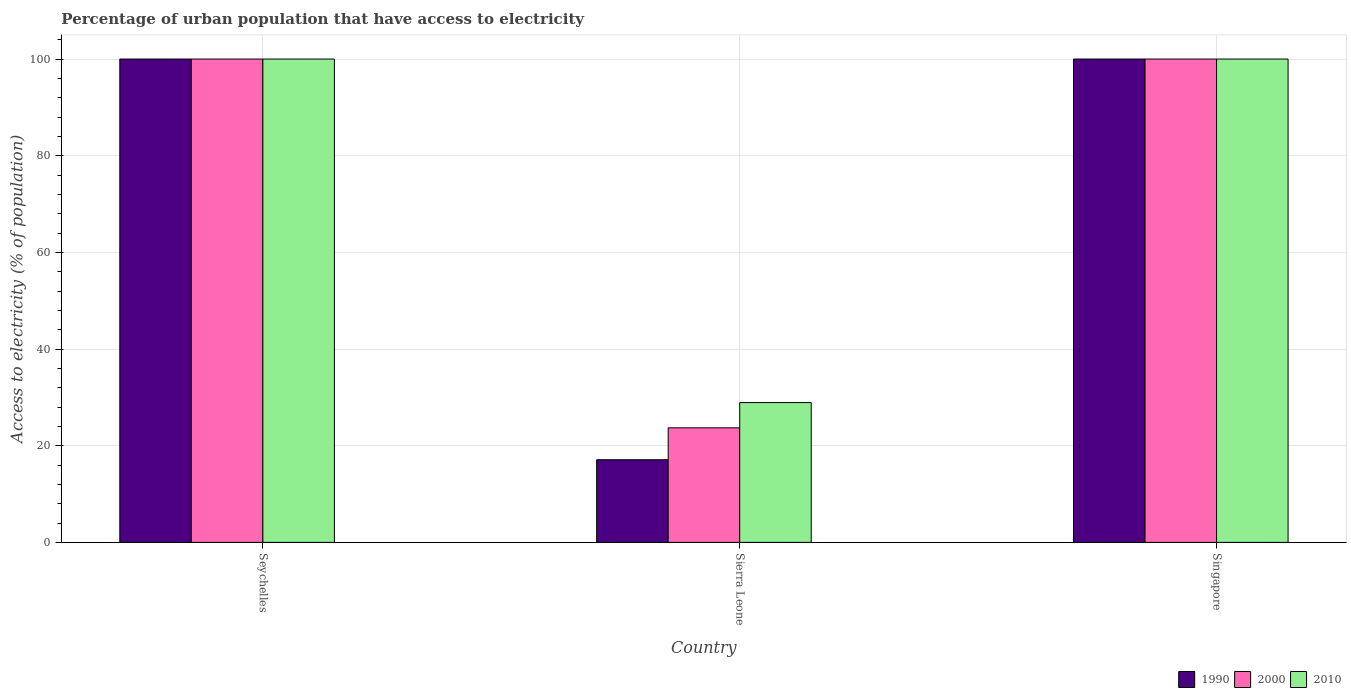Are the number of bars per tick equal to the number of legend labels?
Provide a short and direct response. Yes. How many bars are there on the 2nd tick from the left?
Your response must be concise. 3. What is the label of the 3rd group of bars from the left?
Provide a succinct answer. Singapore. In how many cases, is the number of bars for a given country not equal to the number of legend labels?
Provide a short and direct response. 0. What is the percentage of urban population that have access to electricity in 2000 in Singapore?
Offer a very short reply. 100. Across all countries, what is the maximum percentage of urban population that have access to electricity in 2010?
Provide a succinct answer. 100. Across all countries, what is the minimum percentage of urban population that have access to electricity in 1990?
Provide a short and direct response. 17.1. In which country was the percentage of urban population that have access to electricity in 1990 maximum?
Give a very brief answer. Seychelles. In which country was the percentage of urban population that have access to electricity in 2000 minimum?
Offer a terse response. Sierra Leone. What is the total percentage of urban population that have access to electricity in 2010 in the graph?
Offer a terse response. 228.92. What is the difference between the percentage of urban population that have access to electricity in 1990 in Sierra Leone and that in Singapore?
Provide a succinct answer. -82.9. What is the difference between the percentage of urban population that have access to electricity in 2010 in Sierra Leone and the percentage of urban population that have access to electricity in 2000 in Singapore?
Keep it short and to the point. -71.08. What is the average percentage of urban population that have access to electricity in 2010 per country?
Offer a terse response. 76.31. In how many countries, is the percentage of urban population that have access to electricity in 2010 greater than 64 %?
Ensure brevity in your answer.  2. What is the ratio of the percentage of urban population that have access to electricity in 1990 in Sierra Leone to that in Singapore?
Your answer should be very brief. 0.17. Is the percentage of urban population that have access to electricity in 2010 in Seychelles less than that in Sierra Leone?
Offer a very short reply. No. What is the difference between the highest and the second highest percentage of urban population that have access to electricity in 1990?
Offer a terse response. -82.9. What is the difference between the highest and the lowest percentage of urban population that have access to electricity in 2010?
Provide a succinct answer. 71.08. In how many countries, is the percentage of urban population that have access to electricity in 2010 greater than the average percentage of urban population that have access to electricity in 2010 taken over all countries?
Your answer should be very brief. 2. What does the 3rd bar from the right in Seychelles represents?
Your answer should be very brief. 1990. Is it the case that in every country, the sum of the percentage of urban population that have access to electricity in 1990 and percentage of urban population that have access to electricity in 2000 is greater than the percentage of urban population that have access to electricity in 2010?
Give a very brief answer. Yes. Are all the bars in the graph horizontal?
Ensure brevity in your answer.  No. How many countries are there in the graph?
Provide a succinct answer. 3. Does the graph contain any zero values?
Your answer should be very brief. No. Does the graph contain grids?
Your answer should be compact. Yes. How are the legend labels stacked?
Offer a terse response. Horizontal. What is the title of the graph?
Ensure brevity in your answer.  Percentage of urban population that have access to electricity. Does "2003" appear as one of the legend labels in the graph?
Offer a very short reply. No. What is the label or title of the Y-axis?
Offer a terse response. Access to electricity (% of population). What is the Access to electricity (% of population) of 1990 in Seychelles?
Give a very brief answer. 100. What is the Access to electricity (% of population) of 1990 in Sierra Leone?
Your answer should be compact. 17.1. What is the Access to electricity (% of population) in 2000 in Sierra Leone?
Provide a short and direct response. 23.7. What is the Access to electricity (% of population) in 2010 in Sierra Leone?
Provide a succinct answer. 28.92. What is the Access to electricity (% of population) of 1990 in Singapore?
Provide a short and direct response. 100. What is the Access to electricity (% of population) in 2000 in Singapore?
Your answer should be compact. 100. What is the Access to electricity (% of population) of 2010 in Singapore?
Your response must be concise. 100. Across all countries, what is the maximum Access to electricity (% of population) of 1990?
Keep it short and to the point. 100. Across all countries, what is the maximum Access to electricity (% of population) of 2010?
Your answer should be compact. 100. Across all countries, what is the minimum Access to electricity (% of population) of 1990?
Your response must be concise. 17.1. Across all countries, what is the minimum Access to electricity (% of population) of 2000?
Your answer should be compact. 23.7. Across all countries, what is the minimum Access to electricity (% of population) of 2010?
Your answer should be compact. 28.92. What is the total Access to electricity (% of population) in 1990 in the graph?
Keep it short and to the point. 217.1. What is the total Access to electricity (% of population) of 2000 in the graph?
Ensure brevity in your answer.  223.7. What is the total Access to electricity (% of population) of 2010 in the graph?
Provide a short and direct response. 228.92. What is the difference between the Access to electricity (% of population) in 1990 in Seychelles and that in Sierra Leone?
Your answer should be very brief. 82.9. What is the difference between the Access to electricity (% of population) of 2000 in Seychelles and that in Sierra Leone?
Offer a terse response. 76.3. What is the difference between the Access to electricity (% of population) in 2010 in Seychelles and that in Sierra Leone?
Give a very brief answer. 71.08. What is the difference between the Access to electricity (% of population) in 2000 in Seychelles and that in Singapore?
Your answer should be compact. 0. What is the difference between the Access to electricity (% of population) in 1990 in Sierra Leone and that in Singapore?
Give a very brief answer. -82.9. What is the difference between the Access to electricity (% of population) in 2000 in Sierra Leone and that in Singapore?
Keep it short and to the point. -76.3. What is the difference between the Access to electricity (% of population) of 2010 in Sierra Leone and that in Singapore?
Provide a short and direct response. -71.08. What is the difference between the Access to electricity (% of population) in 1990 in Seychelles and the Access to electricity (% of population) in 2000 in Sierra Leone?
Offer a terse response. 76.3. What is the difference between the Access to electricity (% of population) of 1990 in Seychelles and the Access to electricity (% of population) of 2010 in Sierra Leone?
Make the answer very short. 71.08. What is the difference between the Access to electricity (% of population) of 2000 in Seychelles and the Access to electricity (% of population) of 2010 in Sierra Leone?
Your answer should be very brief. 71.08. What is the difference between the Access to electricity (% of population) in 1990 in Seychelles and the Access to electricity (% of population) in 2010 in Singapore?
Keep it short and to the point. 0. What is the difference between the Access to electricity (% of population) in 1990 in Sierra Leone and the Access to electricity (% of population) in 2000 in Singapore?
Keep it short and to the point. -82.9. What is the difference between the Access to electricity (% of population) of 1990 in Sierra Leone and the Access to electricity (% of population) of 2010 in Singapore?
Your response must be concise. -82.9. What is the difference between the Access to electricity (% of population) in 2000 in Sierra Leone and the Access to electricity (% of population) in 2010 in Singapore?
Make the answer very short. -76.3. What is the average Access to electricity (% of population) of 1990 per country?
Give a very brief answer. 72.37. What is the average Access to electricity (% of population) of 2000 per country?
Provide a short and direct response. 74.57. What is the average Access to electricity (% of population) in 2010 per country?
Your answer should be very brief. 76.31. What is the difference between the Access to electricity (% of population) in 1990 and Access to electricity (% of population) in 2000 in Seychelles?
Give a very brief answer. 0. What is the difference between the Access to electricity (% of population) in 1990 and Access to electricity (% of population) in 2010 in Seychelles?
Your answer should be very brief. 0. What is the difference between the Access to electricity (% of population) in 2000 and Access to electricity (% of population) in 2010 in Seychelles?
Provide a succinct answer. 0. What is the difference between the Access to electricity (% of population) of 1990 and Access to electricity (% of population) of 2000 in Sierra Leone?
Offer a terse response. -6.6. What is the difference between the Access to electricity (% of population) of 1990 and Access to electricity (% of population) of 2010 in Sierra Leone?
Keep it short and to the point. -11.82. What is the difference between the Access to electricity (% of population) in 2000 and Access to electricity (% of population) in 2010 in Sierra Leone?
Keep it short and to the point. -5.22. What is the difference between the Access to electricity (% of population) in 2000 and Access to electricity (% of population) in 2010 in Singapore?
Your response must be concise. 0. What is the ratio of the Access to electricity (% of population) in 1990 in Seychelles to that in Sierra Leone?
Your answer should be very brief. 5.85. What is the ratio of the Access to electricity (% of population) in 2000 in Seychelles to that in Sierra Leone?
Ensure brevity in your answer.  4.22. What is the ratio of the Access to electricity (% of population) in 2010 in Seychelles to that in Sierra Leone?
Your answer should be compact. 3.46. What is the ratio of the Access to electricity (% of population) in 2000 in Seychelles to that in Singapore?
Make the answer very short. 1. What is the ratio of the Access to electricity (% of population) in 2010 in Seychelles to that in Singapore?
Provide a succinct answer. 1. What is the ratio of the Access to electricity (% of population) in 1990 in Sierra Leone to that in Singapore?
Your answer should be very brief. 0.17. What is the ratio of the Access to electricity (% of population) of 2000 in Sierra Leone to that in Singapore?
Offer a very short reply. 0.24. What is the ratio of the Access to electricity (% of population) of 2010 in Sierra Leone to that in Singapore?
Offer a very short reply. 0.29. What is the difference between the highest and the second highest Access to electricity (% of population) in 1990?
Your answer should be compact. 0. What is the difference between the highest and the second highest Access to electricity (% of population) in 2000?
Offer a terse response. 0. What is the difference between the highest and the lowest Access to electricity (% of population) in 1990?
Offer a terse response. 82.9. What is the difference between the highest and the lowest Access to electricity (% of population) of 2000?
Ensure brevity in your answer.  76.3. What is the difference between the highest and the lowest Access to electricity (% of population) of 2010?
Keep it short and to the point. 71.08. 